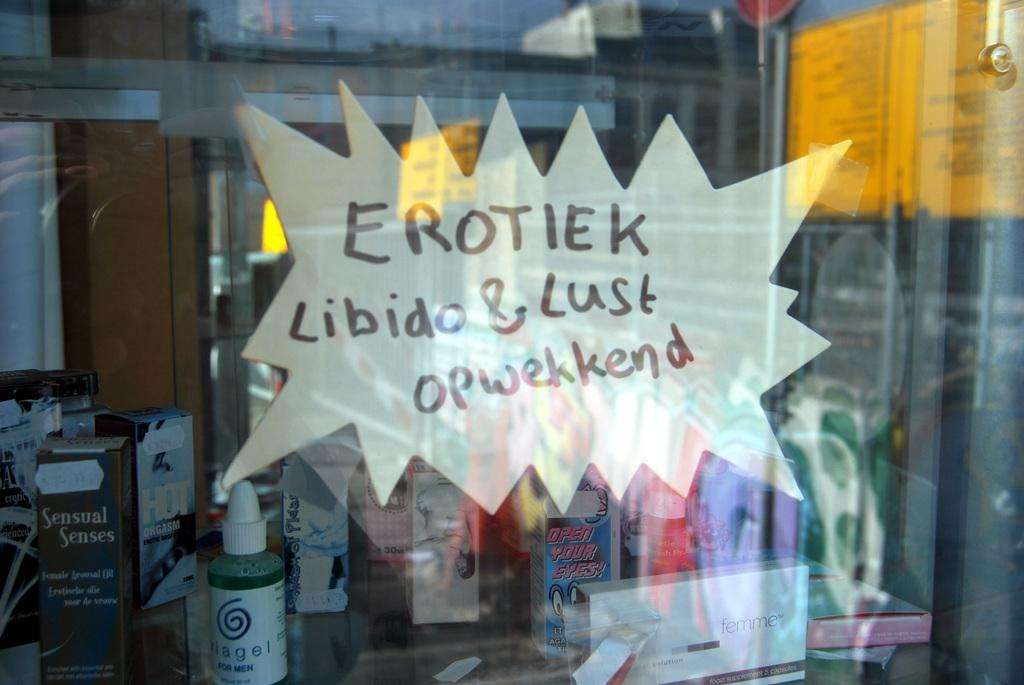What object is present in the image that can hold a liquid? There is a glass in the image. Is there any additional information on the glass? Yes, there is a paper note stuck on the glass. What can be seen through the glass? Few boxes and a bottle are visible through the glass. What scent can be detected from the glass in the image? There is no information about a scent in the image; it only shows a glass with a paper note and objects visible through it. 